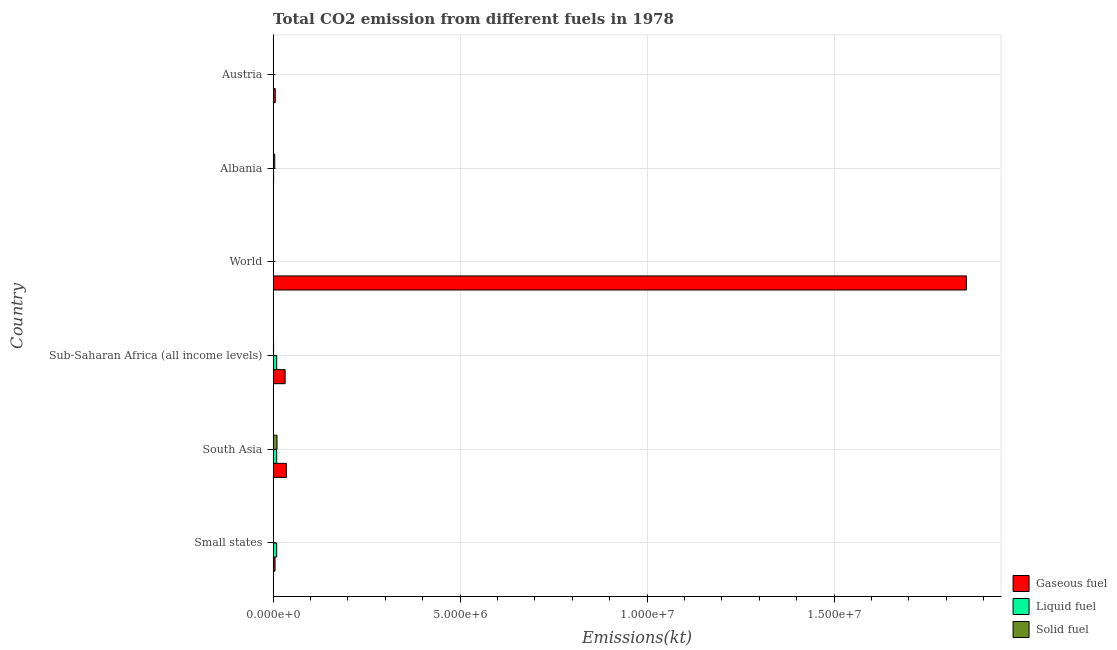How many groups of bars are there?
Provide a succinct answer. 6. Are the number of bars per tick equal to the number of legend labels?
Provide a short and direct response. Yes. Are the number of bars on each tick of the Y-axis equal?
Your answer should be very brief. Yes. How many bars are there on the 2nd tick from the top?
Keep it short and to the point. 3. How many bars are there on the 5th tick from the bottom?
Offer a very short reply. 3. What is the label of the 3rd group of bars from the top?
Ensure brevity in your answer.  World. What is the amount of co2 emissions from gaseous fuel in Albania?
Provide a short and direct response. 6494.26. Across all countries, what is the maximum amount of co2 emissions from solid fuel?
Your answer should be compact. 1.04e+05. Across all countries, what is the minimum amount of co2 emissions from liquid fuel?
Your response must be concise. 935.09. In which country was the amount of co2 emissions from gaseous fuel maximum?
Offer a terse response. World. In which country was the amount of co2 emissions from liquid fuel minimum?
Provide a succinct answer. World. What is the total amount of co2 emissions from solid fuel in the graph?
Provide a short and direct response. 1.66e+05. What is the difference between the amount of co2 emissions from liquid fuel in Albania and that in Austria?
Your answer should be compact. 6732.61. What is the difference between the amount of co2 emissions from gaseous fuel in World and the amount of co2 emissions from liquid fuel in Sub-Saharan Africa (all income levels)?
Provide a short and direct response. 1.84e+07. What is the average amount of co2 emissions from solid fuel per country?
Your answer should be compact. 2.76e+04. What is the difference between the amount of co2 emissions from solid fuel and amount of co2 emissions from liquid fuel in Albania?
Make the answer very short. 3.05e+04. In how many countries, is the amount of co2 emissions from gaseous fuel greater than 16000000 kt?
Your response must be concise. 1. What is the ratio of the amount of co2 emissions from liquid fuel in Small states to that in World?
Provide a short and direct response. 102.35. What is the difference between the highest and the second highest amount of co2 emissions from liquid fuel?
Your answer should be compact. 19.82. What is the difference between the highest and the lowest amount of co2 emissions from solid fuel?
Provide a succinct answer. 1.04e+05. What does the 2nd bar from the top in South Asia represents?
Keep it short and to the point. Liquid fuel. What does the 1st bar from the bottom in Albania represents?
Ensure brevity in your answer.  Gaseous fuel. Is it the case that in every country, the sum of the amount of co2 emissions from gaseous fuel and amount of co2 emissions from liquid fuel is greater than the amount of co2 emissions from solid fuel?
Keep it short and to the point. No. How many bars are there?
Your answer should be compact. 18. Are the values on the major ticks of X-axis written in scientific E-notation?
Your answer should be compact. Yes. Does the graph contain any zero values?
Your response must be concise. No. Does the graph contain grids?
Your answer should be compact. Yes. How many legend labels are there?
Your answer should be very brief. 3. What is the title of the graph?
Your response must be concise. Total CO2 emission from different fuels in 1978. Does "Profit Tax" appear as one of the legend labels in the graph?
Provide a succinct answer. No. What is the label or title of the X-axis?
Provide a short and direct response. Emissions(kt). What is the Emissions(kt) in Gaseous fuel in Small states?
Your answer should be very brief. 5.12e+04. What is the Emissions(kt) in Liquid fuel in Small states?
Your answer should be very brief. 9.57e+04. What is the Emissions(kt) in Solid fuel in Small states?
Provide a short and direct response. 3835.68. What is the Emissions(kt) in Gaseous fuel in South Asia?
Your answer should be compact. 3.56e+05. What is the Emissions(kt) of Liquid fuel in South Asia?
Your response must be concise. 9.57e+04. What is the Emissions(kt) in Solid fuel in South Asia?
Your answer should be very brief. 1.04e+05. What is the Emissions(kt) in Gaseous fuel in Sub-Saharan Africa (all income levels)?
Make the answer very short. 3.21e+05. What is the Emissions(kt) of Liquid fuel in Sub-Saharan Africa (all income levels)?
Your response must be concise. 9.56e+04. What is the Emissions(kt) of Solid fuel in Sub-Saharan Africa (all income levels)?
Keep it short and to the point. 1.28e+04. What is the Emissions(kt) in Gaseous fuel in World?
Keep it short and to the point. 1.85e+07. What is the Emissions(kt) of Liquid fuel in World?
Keep it short and to the point. 935.09. What is the Emissions(kt) in Solid fuel in World?
Keep it short and to the point. 421.7. What is the Emissions(kt) of Gaseous fuel in Albania?
Give a very brief answer. 6494.26. What is the Emissions(kt) of Liquid fuel in Albania?
Give a very brief answer. 1.32e+04. What is the Emissions(kt) in Solid fuel in Albania?
Offer a terse response. 4.37e+04. What is the Emissions(kt) in Gaseous fuel in Austria?
Offer a very short reply. 5.75e+04. What is the Emissions(kt) of Liquid fuel in Austria?
Make the answer very short. 6442.92. What is the Emissions(kt) of Solid fuel in Austria?
Give a very brief answer. 832.41. Across all countries, what is the maximum Emissions(kt) in Gaseous fuel?
Your response must be concise. 1.85e+07. Across all countries, what is the maximum Emissions(kt) in Liquid fuel?
Give a very brief answer. 9.57e+04. Across all countries, what is the maximum Emissions(kt) in Solid fuel?
Provide a succinct answer. 1.04e+05. Across all countries, what is the minimum Emissions(kt) of Gaseous fuel?
Give a very brief answer. 6494.26. Across all countries, what is the minimum Emissions(kt) of Liquid fuel?
Offer a terse response. 935.09. Across all countries, what is the minimum Emissions(kt) in Solid fuel?
Provide a succinct answer. 421.7. What is the total Emissions(kt) in Gaseous fuel in the graph?
Make the answer very short. 1.93e+07. What is the total Emissions(kt) of Liquid fuel in the graph?
Your response must be concise. 3.08e+05. What is the total Emissions(kt) of Solid fuel in the graph?
Keep it short and to the point. 1.66e+05. What is the difference between the Emissions(kt) of Gaseous fuel in Small states and that in South Asia?
Provide a succinct answer. -3.05e+05. What is the difference between the Emissions(kt) in Liquid fuel in Small states and that in South Asia?
Make the answer very short. -19.82. What is the difference between the Emissions(kt) of Solid fuel in Small states and that in South Asia?
Your response must be concise. -1.00e+05. What is the difference between the Emissions(kt) in Gaseous fuel in Small states and that in Sub-Saharan Africa (all income levels)?
Keep it short and to the point. -2.69e+05. What is the difference between the Emissions(kt) of Liquid fuel in Small states and that in Sub-Saharan Africa (all income levels)?
Keep it short and to the point. 122.23. What is the difference between the Emissions(kt) in Solid fuel in Small states and that in Sub-Saharan Africa (all income levels)?
Offer a very short reply. -9009.82. What is the difference between the Emissions(kt) in Gaseous fuel in Small states and that in World?
Make the answer very short. -1.85e+07. What is the difference between the Emissions(kt) of Liquid fuel in Small states and that in World?
Provide a short and direct response. 9.48e+04. What is the difference between the Emissions(kt) of Solid fuel in Small states and that in World?
Keep it short and to the point. 3413.98. What is the difference between the Emissions(kt) in Gaseous fuel in Small states and that in Albania?
Ensure brevity in your answer.  4.47e+04. What is the difference between the Emissions(kt) in Liquid fuel in Small states and that in Albania?
Ensure brevity in your answer.  8.25e+04. What is the difference between the Emissions(kt) of Solid fuel in Small states and that in Albania?
Your response must be concise. -3.98e+04. What is the difference between the Emissions(kt) of Gaseous fuel in Small states and that in Austria?
Offer a very short reply. -6306.04. What is the difference between the Emissions(kt) of Liquid fuel in Small states and that in Austria?
Offer a terse response. 8.93e+04. What is the difference between the Emissions(kt) of Solid fuel in Small states and that in Austria?
Offer a terse response. 3003.27. What is the difference between the Emissions(kt) of Gaseous fuel in South Asia and that in Sub-Saharan Africa (all income levels)?
Offer a terse response. 3.55e+04. What is the difference between the Emissions(kt) of Liquid fuel in South Asia and that in Sub-Saharan Africa (all income levels)?
Your response must be concise. 142.05. What is the difference between the Emissions(kt) in Solid fuel in South Asia and that in Sub-Saharan Africa (all income levels)?
Ensure brevity in your answer.  9.13e+04. What is the difference between the Emissions(kt) of Gaseous fuel in South Asia and that in World?
Your response must be concise. -1.82e+07. What is the difference between the Emissions(kt) of Liquid fuel in South Asia and that in World?
Your answer should be very brief. 9.48e+04. What is the difference between the Emissions(kt) in Solid fuel in South Asia and that in World?
Ensure brevity in your answer.  1.04e+05. What is the difference between the Emissions(kt) in Gaseous fuel in South Asia and that in Albania?
Ensure brevity in your answer.  3.50e+05. What is the difference between the Emissions(kt) of Liquid fuel in South Asia and that in Albania?
Offer a very short reply. 8.25e+04. What is the difference between the Emissions(kt) in Solid fuel in South Asia and that in Albania?
Your answer should be compact. 6.05e+04. What is the difference between the Emissions(kt) in Gaseous fuel in South Asia and that in Austria?
Provide a succinct answer. 2.99e+05. What is the difference between the Emissions(kt) of Liquid fuel in South Asia and that in Austria?
Provide a short and direct response. 8.93e+04. What is the difference between the Emissions(kt) in Solid fuel in South Asia and that in Austria?
Make the answer very short. 1.03e+05. What is the difference between the Emissions(kt) in Gaseous fuel in Sub-Saharan Africa (all income levels) and that in World?
Ensure brevity in your answer.  -1.82e+07. What is the difference between the Emissions(kt) in Liquid fuel in Sub-Saharan Africa (all income levels) and that in World?
Keep it short and to the point. 9.46e+04. What is the difference between the Emissions(kt) in Solid fuel in Sub-Saharan Africa (all income levels) and that in World?
Offer a terse response. 1.24e+04. What is the difference between the Emissions(kt) in Gaseous fuel in Sub-Saharan Africa (all income levels) and that in Albania?
Give a very brief answer. 3.14e+05. What is the difference between the Emissions(kt) of Liquid fuel in Sub-Saharan Africa (all income levels) and that in Albania?
Make the answer very short. 8.24e+04. What is the difference between the Emissions(kt) in Solid fuel in Sub-Saharan Africa (all income levels) and that in Albania?
Provide a short and direct response. -3.08e+04. What is the difference between the Emissions(kt) in Gaseous fuel in Sub-Saharan Africa (all income levels) and that in Austria?
Ensure brevity in your answer.  2.63e+05. What is the difference between the Emissions(kt) in Liquid fuel in Sub-Saharan Africa (all income levels) and that in Austria?
Your answer should be compact. 8.91e+04. What is the difference between the Emissions(kt) of Solid fuel in Sub-Saharan Africa (all income levels) and that in Austria?
Ensure brevity in your answer.  1.20e+04. What is the difference between the Emissions(kt) in Gaseous fuel in World and that in Albania?
Provide a short and direct response. 1.85e+07. What is the difference between the Emissions(kt) of Liquid fuel in World and that in Albania?
Keep it short and to the point. -1.22e+04. What is the difference between the Emissions(kt) of Solid fuel in World and that in Albania?
Your response must be concise. -4.33e+04. What is the difference between the Emissions(kt) of Gaseous fuel in World and that in Austria?
Ensure brevity in your answer.  1.85e+07. What is the difference between the Emissions(kt) in Liquid fuel in World and that in Austria?
Your answer should be very brief. -5507.83. What is the difference between the Emissions(kt) in Solid fuel in World and that in Austria?
Ensure brevity in your answer.  -410.7. What is the difference between the Emissions(kt) in Gaseous fuel in Albania and that in Austria?
Offer a terse response. -5.10e+04. What is the difference between the Emissions(kt) of Liquid fuel in Albania and that in Austria?
Provide a short and direct response. 6732.61. What is the difference between the Emissions(kt) in Solid fuel in Albania and that in Austria?
Offer a very short reply. 4.29e+04. What is the difference between the Emissions(kt) of Gaseous fuel in Small states and the Emissions(kt) of Liquid fuel in South Asia?
Ensure brevity in your answer.  -4.45e+04. What is the difference between the Emissions(kt) in Gaseous fuel in Small states and the Emissions(kt) in Solid fuel in South Asia?
Your response must be concise. -5.30e+04. What is the difference between the Emissions(kt) in Liquid fuel in Small states and the Emissions(kt) in Solid fuel in South Asia?
Your answer should be very brief. -8459.77. What is the difference between the Emissions(kt) in Gaseous fuel in Small states and the Emissions(kt) in Liquid fuel in Sub-Saharan Africa (all income levels)?
Provide a succinct answer. -4.44e+04. What is the difference between the Emissions(kt) in Gaseous fuel in Small states and the Emissions(kt) in Solid fuel in Sub-Saharan Africa (all income levels)?
Make the answer very short. 3.83e+04. What is the difference between the Emissions(kt) in Liquid fuel in Small states and the Emissions(kt) in Solid fuel in Sub-Saharan Africa (all income levels)?
Provide a short and direct response. 8.29e+04. What is the difference between the Emissions(kt) in Gaseous fuel in Small states and the Emissions(kt) in Liquid fuel in World?
Offer a terse response. 5.02e+04. What is the difference between the Emissions(kt) in Gaseous fuel in Small states and the Emissions(kt) in Solid fuel in World?
Your answer should be compact. 5.08e+04. What is the difference between the Emissions(kt) in Liquid fuel in Small states and the Emissions(kt) in Solid fuel in World?
Your answer should be very brief. 9.53e+04. What is the difference between the Emissions(kt) of Gaseous fuel in Small states and the Emissions(kt) of Liquid fuel in Albania?
Offer a very short reply. 3.80e+04. What is the difference between the Emissions(kt) of Gaseous fuel in Small states and the Emissions(kt) of Solid fuel in Albania?
Your answer should be compact. 7492.88. What is the difference between the Emissions(kt) of Liquid fuel in Small states and the Emissions(kt) of Solid fuel in Albania?
Keep it short and to the point. 5.20e+04. What is the difference between the Emissions(kt) of Gaseous fuel in Small states and the Emissions(kt) of Liquid fuel in Austria?
Offer a terse response. 4.47e+04. What is the difference between the Emissions(kt) in Gaseous fuel in Small states and the Emissions(kt) in Solid fuel in Austria?
Ensure brevity in your answer.  5.03e+04. What is the difference between the Emissions(kt) in Liquid fuel in Small states and the Emissions(kt) in Solid fuel in Austria?
Provide a short and direct response. 9.49e+04. What is the difference between the Emissions(kt) of Gaseous fuel in South Asia and the Emissions(kt) of Liquid fuel in Sub-Saharan Africa (all income levels)?
Ensure brevity in your answer.  2.61e+05. What is the difference between the Emissions(kt) in Gaseous fuel in South Asia and the Emissions(kt) in Solid fuel in Sub-Saharan Africa (all income levels)?
Provide a succinct answer. 3.43e+05. What is the difference between the Emissions(kt) in Liquid fuel in South Asia and the Emissions(kt) in Solid fuel in Sub-Saharan Africa (all income levels)?
Your response must be concise. 8.29e+04. What is the difference between the Emissions(kt) in Gaseous fuel in South Asia and the Emissions(kt) in Liquid fuel in World?
Your response must be concise. 3.55e+05. What is the difference between the Emissions(kt) of Gaseous fuel in South Asia and the Emissions(kt) of Solid fuel in World?
Offer a very short reply. 3.56e+05. What is the difference between the Emissions(kt) of Liquid fuel in South Asia and the Emissions(kt) of Solid fuel in World?
Your response must be concise. 9.53e+04. What is the difference between the Emissions(kt) in Gaseous fuel in South Asia and the Emissions(kt) in Liquid fuel in Albania?
Your response must be concise. 3.43e+05. What is the difference between the Emissions(kt) of Gaseous fuel in South Asia and the Emissions(kt) of Solid fuel in Albania?
Make the answer very short. 3.12e+05. What is the difference between the Emissions(kt) of Liquid fuel in South Asia and the Emissions(kt) of Solid fuel in Albania?
Your answer should be compact. 5.20e+04. What is the difference between the Emissions(kt) of Gaseous fuel in South Asia and the Emissions(kt) of Liquid fuel in Austria?
Your response must be concise. 3.50e+05. What is the difference between the Emissions(kt) of Gaseous fuel in South Asia and the Emissions(kt) of Solid fuel in Austria?
Your answer should be compact. 3.55e+05. What is the difference between the Emissions(kt) of Liquid fuel in South Asia and the Emissions(kt) of Solid fuel in Austria?
Make the answer very short. 9.49e+04. What is the difference between the Emissions(kt) in Gaseous fuel in Sub-Saharan Africa (all income levels) and the Emissions(kt) in Liquid fuel in World?
Offer a terse response. 3.20e+05. What is the difference between the Emissions(kt) in Gaseous fuel in Sub-Saharan Africa (all income levels) and the Emissions(kt) in Solid fuel in World?
Offer a terse response. 3.20e+05. What is the difference between the Emissions(kt) in Liquid fuel in Sub-Saharan Africa (all income levels) and the Emissions(kt) in Solid fuel in World?
Keep it short and to the point. 9.52e+04. What is the difference between the Emissions(kt) of Gaseous fuel in Sub-Saharan Africa (all income levels) and the Emissions(kt) of Liquid fuel in Albania?
Your answer should be compact. 3.07e+05. What is the difference between the Emissions(kt) in Gaseous fuel in Sub-Saharan Africa (all income levels) and the Emissions(kt) in Solid fuel in Albania?
Give a very brief answer. 2.77e+05. What is the difference between the Emissions(kt) of Liquid fuel in Sub-Saharan Africa (all income levels) and the Emissions(kt) of Solid fuel in Albania?
Provide a succinct answer. 5.19e+04. What is the difference between the Emissions(kt) in Gaseous fuel in Sub-Saharan Africa (all income levels) and the Emissions(kt) in Liquid fuel in Austria?
Give a very brief answer. 3.14e+05. What is the difference between the Emissions(kt) in Gaseous fuel in Sub-Saharan Africa (all income levels) and the Emissions(kt) in Solid fuel in Austria?
Your answer should be compact. 3.20e+05. What is the difference between the Emissions(kt) of Liquid fuel in Sub-Saharan Africa (all income levels) and the Emissions(kt) of Solid fuel in Austria?
Keep it short and to the point. 9.48e+04. What is the difference between the Emissions(kt) of Gaseous fuel in World and the Emissions(kt) of Liquid fuel in Albania?
Provide a short and direct response. 1.85e+07. What is the difference between the Emissions(kt) in Gaseous fuel in World and the Emissions(kt) in Solid fuel in Albania?
Your answer should be very brief. 1.85e+07. What is the difference between the Emissions(kt) of Liquid fuel in World and the Emissions(kt) of Solid fuel in Albania?
Your answer should be very brief. -4.27e+04. What is the difference between the Emissions(kt) of Gaseous fuel in World and the Emissions(kt) of Liquid fuel in Austria?
Your answer should be very brief. 1.85e+07. What is the difference between the Emissions(kt) in Gaseous fuel in World and the Emissions(kt) in Solid fuel in Austria?
Ensure brevity in your answer.  1.85e+07. What is the difference between the Emissions(kt) of Liquid fuel in World and the Emissions(kt) of Solid fuel in Austria?
Provide a short and direct response. 102.68. What is the difference between the Emissions(kt) in Gaseous fuel in Albania and the Emissions(kt) in Liquid fuel in Austria?
Offer a terse response. 51.34. What is the difference between the Emissions(kt) in Gaseous fuel in Albania and the Emissions(kt) in Solid fuel in Austria?
Your answer should be compact. 5661.85. What is the difference between the Emissions(kt) in Liquid fuel in Albania and the Emissions(kt) in Solid fuel in Austria?
Your response must be concise. 1.23e+04. What is the average Emissions(kt) in Gaseous fuel per country?
Your answer should be compact. 3.22e+06. What is the average Emissions(kt) of Liquid fuel per country?
Offer a very short reply. 5.13e+04. What is the average Emissions(kt) of Solid fuel per country?
Offer a very short reply. 2.76e+04. What is the difference between the Emissions(kt) of Gaseous fuel and Emissions(kt) of Liquid fuel in Small states?
Your answer should be compact. -4.45e+04. What is the difference between the Emissions(kt) of Gaseous fuel and Emissions(kt) of Solid fuel in Small states?
Give a very brief answer. 4.73e+04. What is the difference between the Emissions(kt) of Liquid fuel and Emissions(kt) of Solid fuel in Small states?
Your answer should be compact. 9.19e+04. What is the difference between the Emissions(kt) of Gaseous fuel and Emissions(kt) of Liquid fuel in South Asia?
Provide a short and direct response. 2.60e+05. What is the difference between the Emissions(kt) of Gaseous fuel and Emissions(kt) of Solid fuel in South Asia?
Offer a terse response. 2.52e+05. What is the difference between the Emissions(kt) of Liquid fuel and Emissions(kt) of Solid fuel in South Asia?
Offer a very short reply. -8439.95. What is the difference between the Emissions(kt) in Gaseous fuel and Emissions(kt) in Liquid fuel in Sub-Saharan Africa (all income levels)?
Give a very brief answer. 2.25e+05. What is the difference between the Emissions(kt) in Gaseous fuel and Emissions(kt) in Solid fuel in Sub-Saharan Africa (all income levels)?
Make the answer very short. 3.08e+05. What is the difference between the Emissions(kt) of Liquid fuel and Emissions(kt) of Solid fuel in Sub-Saharan Africa (all income levels)?
Give a very brief answer. 8.27e+04. What is the difference between the Emissions(kt) of Gaseous fuel and Emissions(kt) of Liquid fuel in World?
Offer a very short reply. 1.85e+07. What is the difference between the Emissions(kt) in Gaseous fuel and Emissions(kt) in Solid fuel in World?
Offer a terse response. 1.85e+07. What is the difference between the Emissions(kt) in Liquid fuel and Emissions(kt) in Solid fuel in World?
Offer a terse response. 513.38. What is the difference between the Emissions(kt) of Gaseous fuel and Emissions(kt) of Liquid fuel in Albania?
Your answer should be compact. -6681.27. What is the difference between the Emissions(kt) in Gaseous fuel and Emissions(kt) in Solid fuel in Albania?
Your answer should be very brief. -3.72e+04. What is the difference between the Emissions(kt) of Liquid fuel and Emissions(kt) of Solid fuel in Albania?
Your response must be concise. -3.05e+04. What is the difference between the Emissions(kt) of Gaseous fuel and Emissions(kt) of Liquid fuel in Austria?
Provide a succinct answer. 5.10e+04. What is the difference between the Emissions(kt) in Gaseous fuel and Emissions(kt) in Solid fuel in Austria?
Your response must be concise. 5.67e+04. What is the difference between the Emissions(kt) in Liquid fuel and Emissions(kt) in Solid fuel in Austria?
Ensure brevity in your answer.  5610.51. What is the ratio of the Emissions(kt) in Gaseous fuel in Small states to that in South Asia?
Make the answer very short. 0.14. What is the ratio of the Emissions(kt) of Liquid fuel in Small states to that in South Asia?
Ensure brevity in your answer.  1. What is the ratio of the Emissions(kt) in Solid fuel in Small states to that in South Asia?
Your answer should be very brief. 0.04. What is the ratio of the Emissions(kt) in Gaseous fuel in Small states to that in Sub-Saharan Africa (all income levels)?
Provide a short and direct response. 0.16. What is the ratio of the Emissions(kt) in Liquid fuel in Small states to that in Sub-Saharan Africa (all income levels)?
Ensure brevity in your answer.  1. What is the ratio of the Emissions(kt) of Solid fuel in Small states to that in Sub-Saharan Africa (all income levels)?
Provide a succinct answer. 0.3. What is the ratio of the Emissions(kt) of Gaseous fuel in Small states to that in World?
Your response must be concise. 0. What is the ratio of the Emissions(kt) of Liquid fuel in Small states to that in World?
Offer a terse response. 102.35. What is the ratio of the Emissions(kt) of Solid fuel in Small states to that in World?
Your answer should be compact. 9.1. What is the ratio of the Emissions(kt) in Gaseous fuel in Small states to that in Albania?
Your response must be concise. 7.88. What is the ratio of the Emissions(kt) of Liquid fuel in Small states to that in Albania?
Your answer should be very brief. 7.26. What is the ratio of the Emissions(kt) in Solid fuel in Small states to that in Albania?
Provide a succinct answer. 0.09. What is the ratio of the Emissions(kt) of Gaseous fuel in Small states to that in Austria?
Ensure brevity in your answer.  0.89. What is the ratio of the Emissions(kt) of Liquid fuel in Small states to that in Austria?
Ensure brevity in your answer.  14.85. What is the ratio of the Emissions(kt) of Solid fuel in Small states to that in Austria?
Your response must be concise. 4.61. What is the ratio of the Emissions(kt) in Gaseous fuel in South Asia to that in Sub-Saharan Africa (all income levels)?
Ensure brevity in your answer.  1.11. What is the ratio of the Emissions(kt) in Solid fuel in South Asia to that in Sub-Saharan Africa (all income levels)?
Offer a very short reply. 8.11. What is the ratio of the Emissions(kt) of Gaseous fuel in South Asia to that in World?
Ensure brevity in your answer.  0.02. What is the ratio of the Emissions(kt) in Liquid fuel in South Asia to that in World?
Keep it short and to the point. 102.37. What is the ratio of the Emissions(kt) in Solid fuel in South Asia to that in World?
Provide a succinct answer. 247.01. What is the ratio of the Emissions(kt) of Gaseous fuel in South Asia to that in Albania?
Make the answer very short. 54.84. What is the ratio of the Emissions(kt) in Liquid fuel in South Asia to that in Albania?
Provide a succinct answer. 7.27. What is the ratio of the Emissions(kt) in Solid fuel in South Asia to that in Albania?
Provide a short and direct response. 2.38. What is the ratio of the Emissions(kt) of Gaseous fuel in South Asia to that in Austria?
Provide a succinct answer. 6.2. What is the ratio of the Emissions(kt) of Liquid fuel in South Asia to that in Austria?
Provide a succinct answer. 14.86. What is the ratio of the Emissions(kt) in Solid fuel in South Asia to that in Austria?
Make the answer very short. 125.14. What is the ratio of the Emissions(kt) of Gaseous fuel in Sub-Saharan Africa (all income levels) to that in World?
Provide a succinct answer. 0.02. What is the ratio of the Emissions(kt) in Liquid fuel in Sub-Saharan Africa (all income levels) to that in World?
Make the answer very short. 102.22. What is the ratio of the Emissions(kt) in Solid fuel in Sub-Saharan Africa (all income levels) to that in World?
Give a very brief answer. 30.46. What is the ratio of the Emissions(kt) in Gaseous fuel in Sub-Saharan Africa (all income levels) to that in Albania?
Provide a succinct answer. 49.37. What is the ratio of the Emissions(kt) of Liquid fuel in Sub-Saharan Africa (all income levels) to that in Albania?
Give a very brief answer. 7.25. What is the ratio of the Emissions(kt) in Solid fuel in Sub-Saharan Africa (all income levels) to that in Albania?
Make the answer very short. 0.29. What is the ratio of the Emissions(kt) in Gaseous fuel in Sub-Saharan Africa (all income levels) to that in Austria?
Offer a terse response. 5.58. What is the ratio of the Emissions(kt) in Liquid fuel in Sub-Saharan Africa (all income levels) to that in Austria?
Provide a short and direct response. 14.84. What is the ratio of the Emissions(kt) in Solid fuel in Sub-Saharan Africa (all income levels) to that in Austria?
Your answer should be compact. 15.43. What is the ratio of the Emissions(kt) in Gaseous fuel in World to that in Albania?
Give a very brief answer. 2854.11. What is the ratio of the Emissions(kt) of Liquid fuel in World to that in Albania?
Provide a succinct answer. 0.07. What is the ratio of the Emissions(kt) of Solid fuel in World to that in Albania?
Your response must be concise. 0.01. What is the ratio of the Emissions(kt) of Gaseous fuel in World to that in Austria?
Keep it short and to the point. 322.44. What is the ratio of the Emissions(kt) of Liquid fuel in World to that in Austria?
Ensure brevity in your answer.  0.15. What is the ratio of the Emissions(kt) of Solid fuel in World to that in Austria?
Make the answer very short. 0.51. What is the ratio of the Emissions(kt) in Gaseous fuel in Albania to that in Austria?
Offer a terse response. 0.11. What is the ratio of the Emissions(kt) of Liquid fuel in Albania to that in Austria?
Provide a short and direct response. 2.04. What is the ratio of the Emissions(kt) of Solid fuel in Albania to that in Austria?
Keep it short and to the point. 52.48. What is the difference between the highest and the second highest Emissions(kt) in Gaseous fuel?
Your answer should be compact. 1.82e+07. What is the difference between the highest and the second highest Emissions(kt) of Liquid fuel?
Your answer should be very brief. 19.82. What is the difference between the highest and the second highest Emissions(kt) of Solid fuel?
Provide a succinct answer. 6.05e+04. What is the difference between the highest and the lowest Emissions(kt) of Gaseous fuel?
Give a very brief answer. 1.85e+07. What is the difference between the highest and the lowest Emissions(kt) in Liquid fuel?
Make the answer very short. 9.48e+04. What is the difference between the highest and the lowest Emissions(kt) in Solid fuel?
Your answer should be very brief. 1.04e+05. 